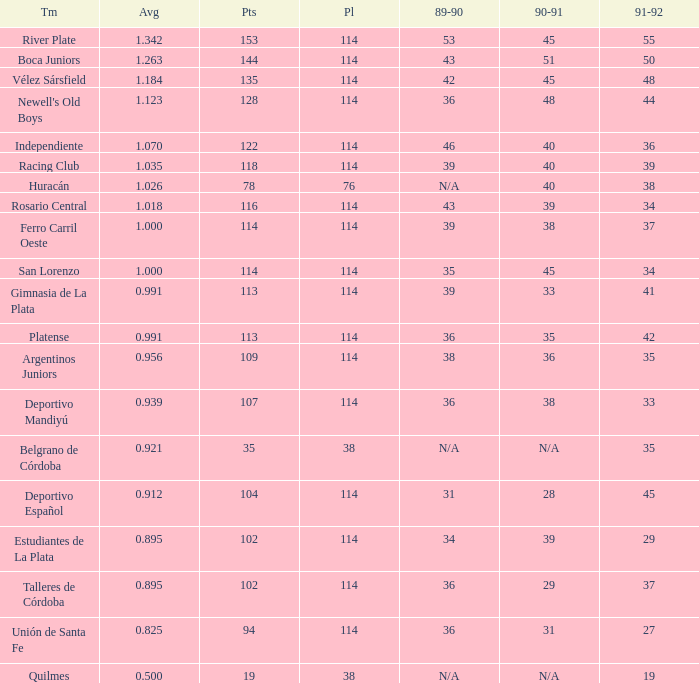How much 1991-1992 has a 1989-90 of 36, and an Average of 0.8250000000000001? 0.0. 